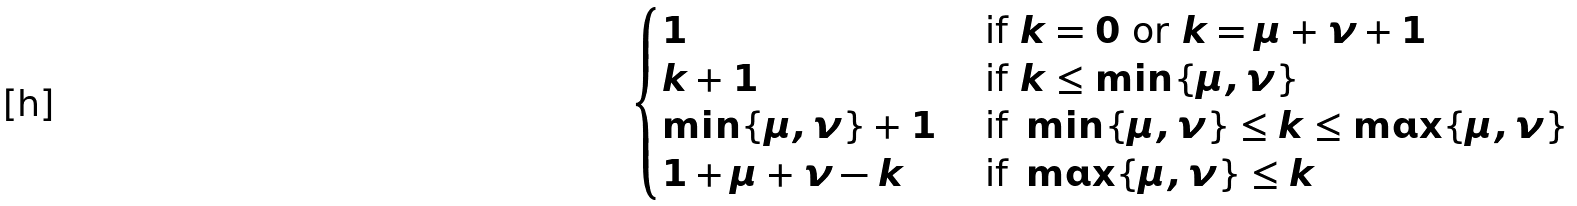<formula> <loc_0><loc_0><loc_500><loc_500>\begin{cases} 1 \quad & \text { if } k = 0 \text { or } k = \mu + \nu + 1 \\ k + 1 & \text { if } k \leq \min \{ \mu , \nu \} \\ \min \{ \mu , \nu \} + 1 & \text { if } \min \{ \mu , \nu \} \leq k \leq \max \{ \mu , \nu \} \\ 1 + \mu + \nu - k & \text { if } \max \{ \mu , \nu \} \leq k \end{cases}</formula> 